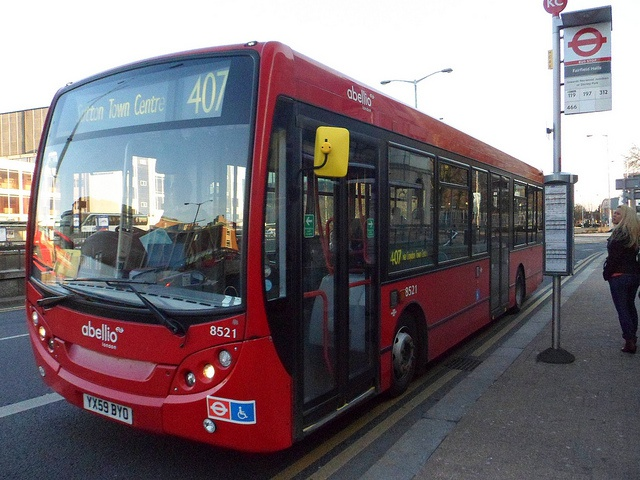Describe the objects in this image and their specific colors. I can see bus in white, black, maroon, and gray tones, people in white, black, and gray tones, and people in white, darkgray, gray, lightblue, and tan tones in this image. 